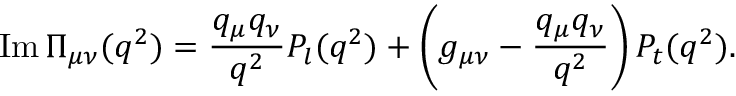Convert formula to latex. <formula><loc_0><loc_0><loc_500><loc_500>I m \, { \Pi _ { \mu \nu } ( q ^ { 2 } ) } = { \frac { q _ { \mu } q _ { \nu } } { q ^ { 2 } } } P _ { l } ( q ^ { 2 } ) + \left ( { g _ { \mu \nu } } - { \frac { q _ { \mu } q _ { \nu } } { q ^ { 2 } } } \right ) P _ { t } ( q ^ { 2 } ) .</formula> 